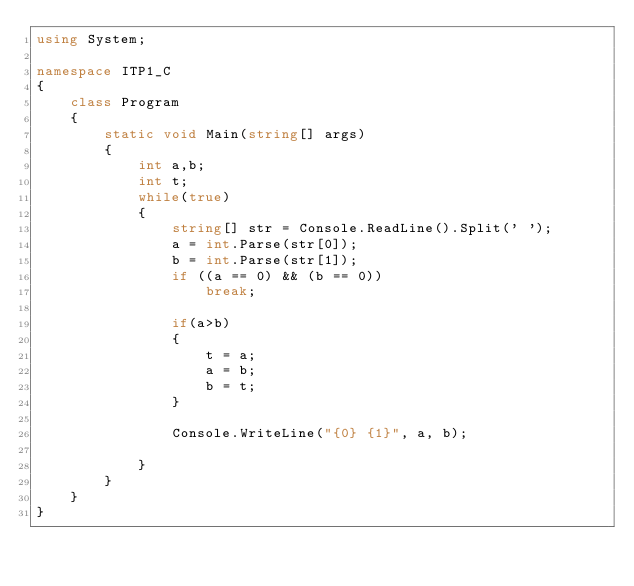Convert code to text. <code><loc_0><loc_0><loc_500><loc_500><_C#_>using System;

namespace ITP1_C
{
    class Program
    {
        static void Main(string[] args)
        {
            int a,b;
            int t;
            while(true)
            {
                string[] str = Console.ReadLine().Split(' ');
                a = int.Parse(str[0]);
                b = int.Parse(str[1]);
                if ((a == 0) && (b == 0))
                    break;

                if(a>b)
                {
                    t = a;
                    a = b;
                    b = t;
                }

                Console.WriteLine("{0} {1}", a, b);

            }
        }
    }
}</code> 